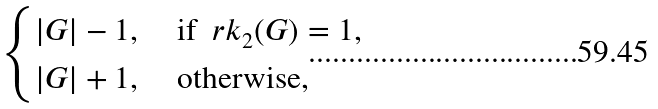<formula> <loc_0><loc_0><loc_500><loc_500>\begin{cases} | G | - 1 , & \text { if } \ r k _ { 2 } ( G ) = 1 , \\ | G | + 1 , & \text { otherwise,} \end{cases}</formula> 